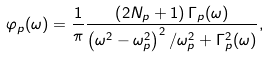<formula> <loc_0><loc_0><loc_500><loc_500>\varphi _ { p } ( \omega ) = \frac { 1 } { \pi } \frac { \left ( 2 N _ { p } + 1 \right ) \Gamma _ { p } ( \omega ) } { \left ( \omega ^ { 2 } - \omega _ { p } ^ { 2 } \right ) ^ { 2 } / \omega _ { p } ^ { 2 } + \Gamma _ { p } ^ { 2 } ( \omega ) } ,</formula> 